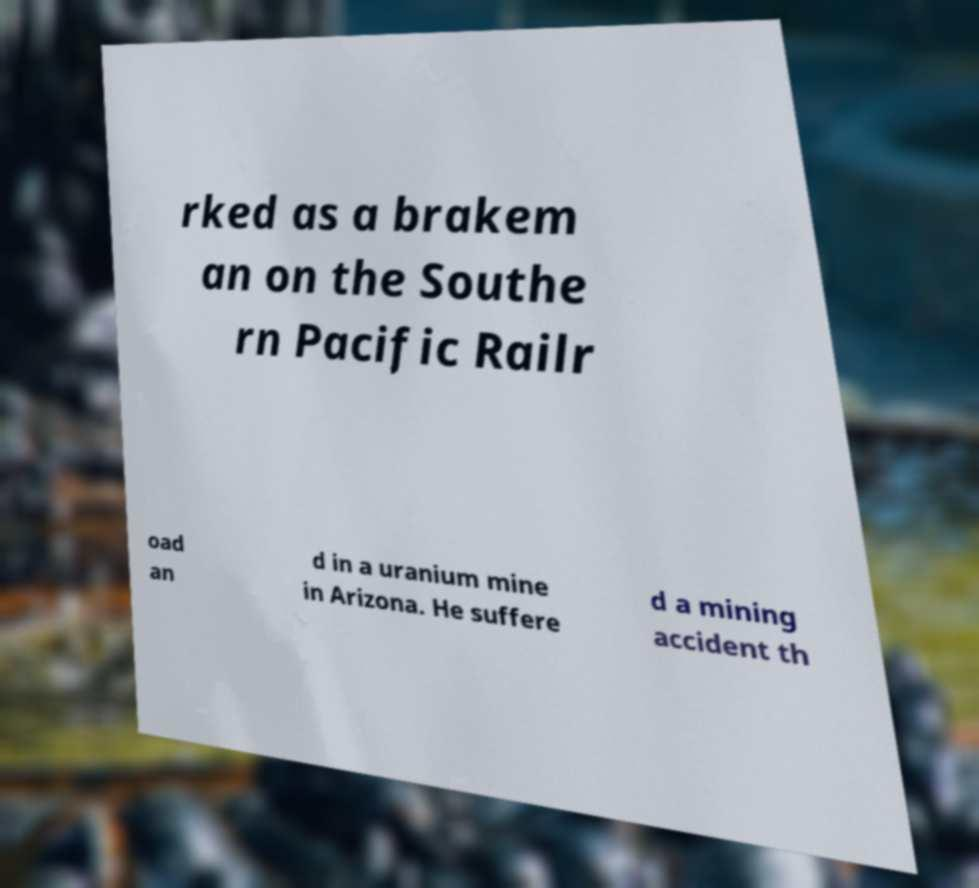What messages or text are displayed in this image? I need them in a readable, typed format. rked as a brakem an on the Southe rn Pacific Railr oad an d in a uranium mine in Arizona. He suffere d a mining accident th 